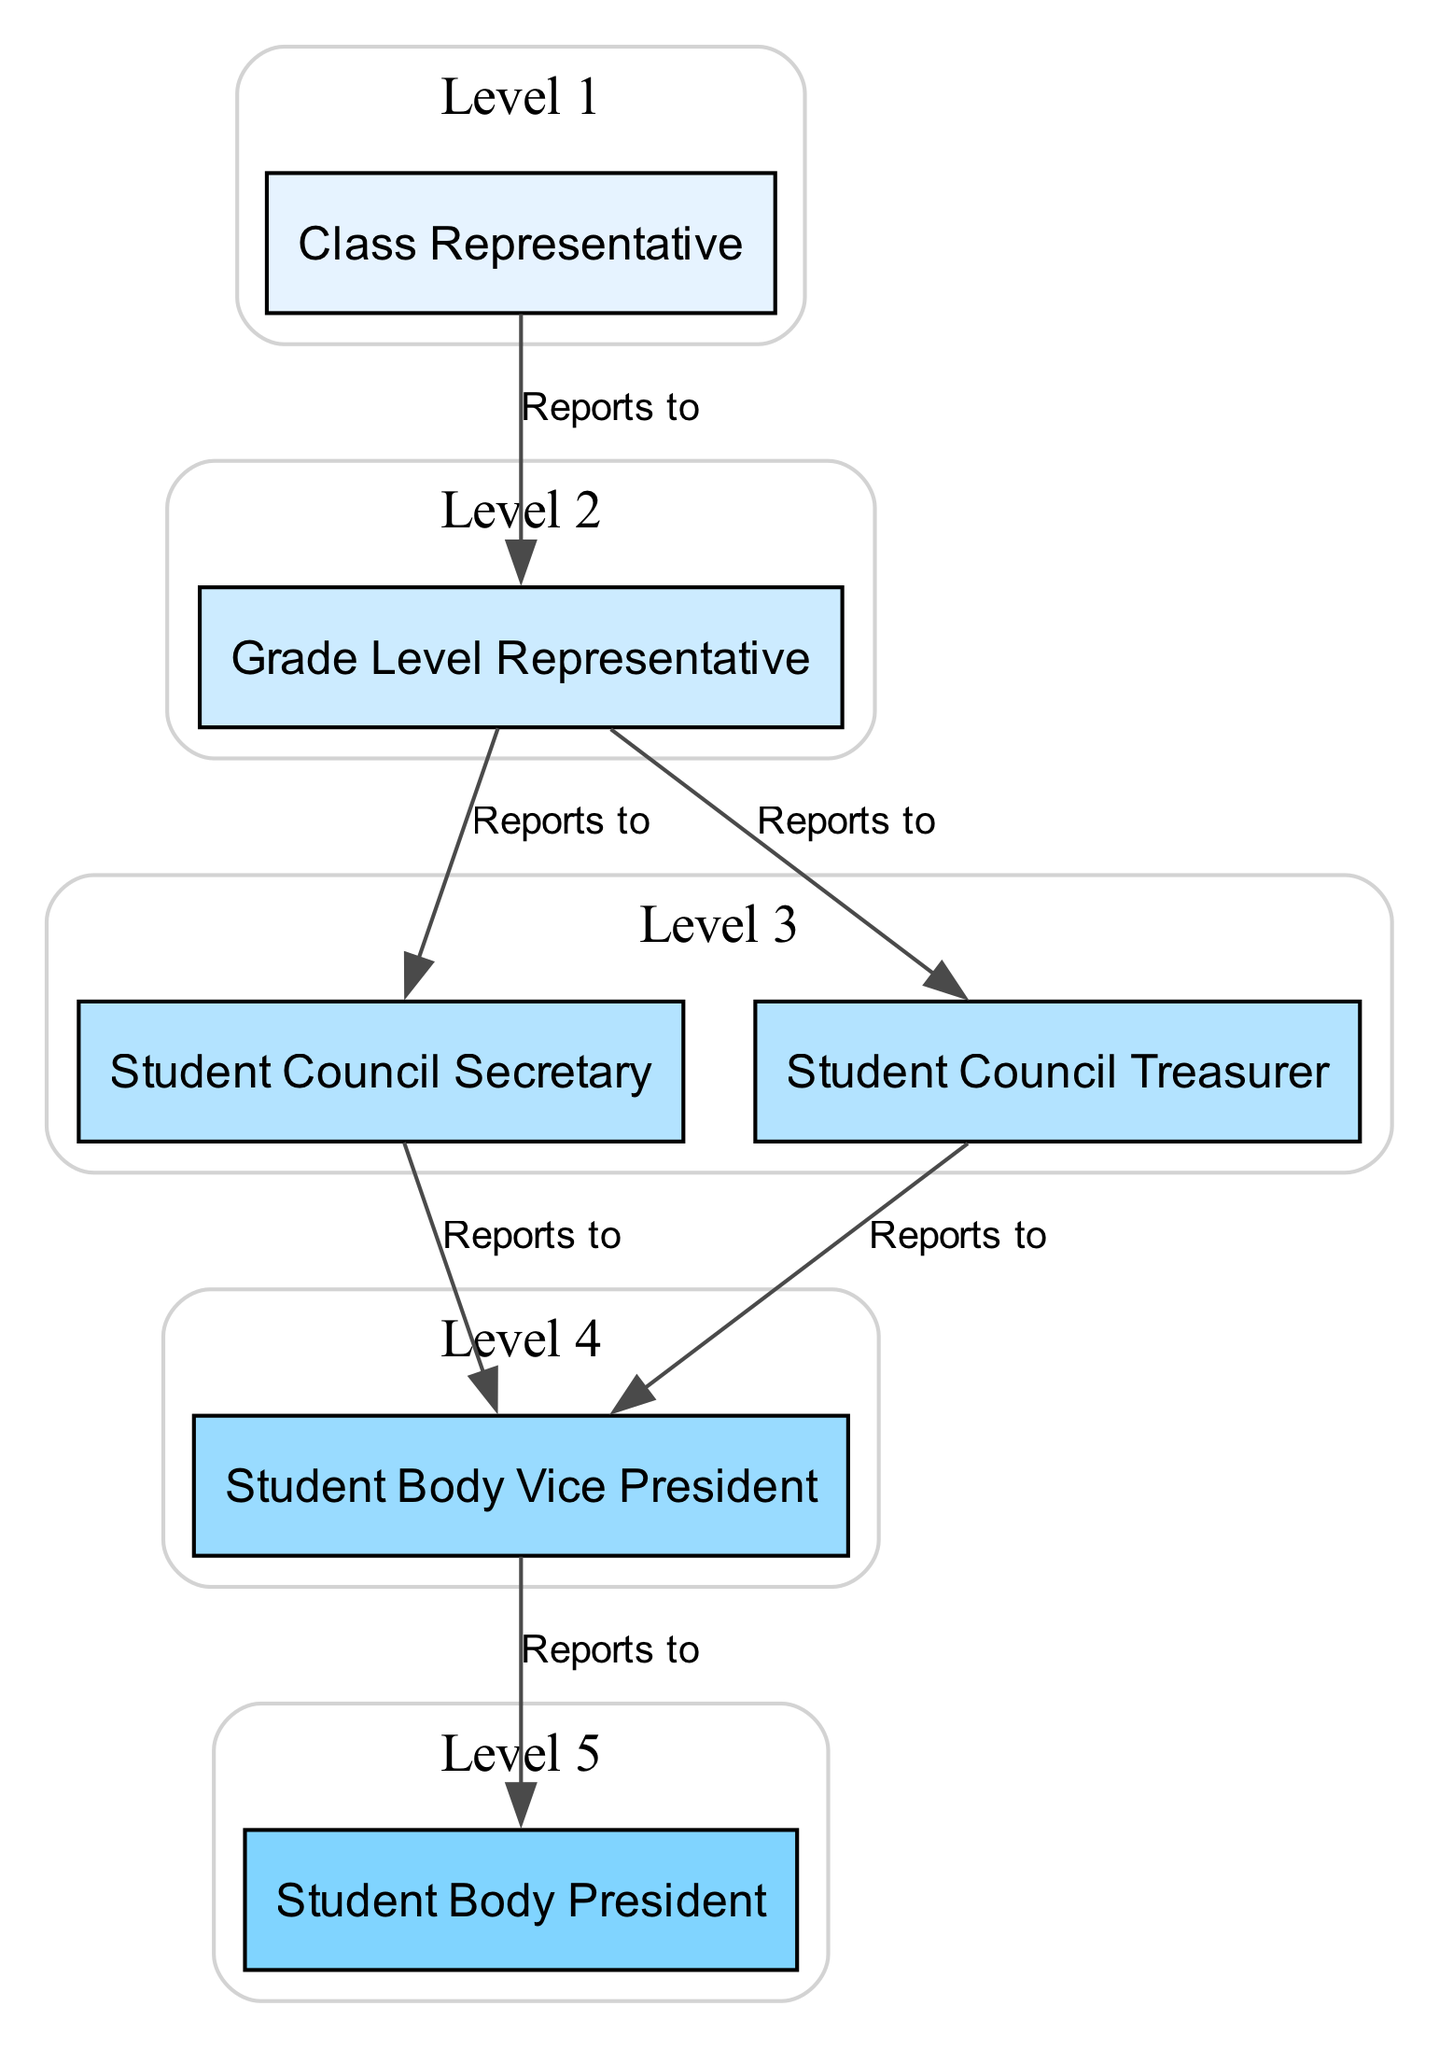What is the highest position in the student government hierarchy? The diagram shows a clear chain of command, with the highest position being the one that does not report to any other. This is the Student Body President.
Answer: Student Body President How many students report directly to the Vice President? To determine this, I look at the edges leading to the Vice President in the diagram. The edges show that both the Student Council Secretary and the Student Council Treasurer report directly to the Vice President. Therefore, the count is two.
Answer: 2 What position is directly below the Student Body President? The diagram indicates direct reporting lines. The Student Body Vice President reports directly to the Student Body President, as shown in the relationship arrow from the Vice President to the President.
Answer: Student Body Vice President Which level does the Class Representative belong to? The Class Representative is identified in the diagram with a specific label. The level of a node is indicated as 'level 1', which places it at the first tier in the hierarchy of the student government organization.
Answer: Level 1 What is the total number of roles depicted in the diagram? By counting the distinct elements listed in the diagram data, I see there are six roles: Class Representative, Grade Level Representative, Student Council Secretary, Student Council Treasurer, Student Body Vice President, and Student Body President. Thus, the total equals six.
Answer: 6 Which two positions share the same level in the hierarchy? The diagram indicates that the Student Council Secretary and Student Council Treasurer both fall under level three. By referencing the levels in the data, I can confirm these roles are equivalent in the hierarchy.
Answer: Student Council Secretary and Student Council Treasurer Who does the Grade Level Representative report to? The Grade Level Representative has arrows leading to both the Student Council Secretary and the Student Council Treasurer in the diagram, indicating it reports to both roles.
Answer: Student Council Secretary and Student Council Treasurer What is the relationship between the Class Representative and the Grade Level Representative? The diagram shows a directional relationship where the Class Representative reports to the Grade Level Representative, visualized with an arrow pointing from the Class Representative to the Grade Level Representative.
Answer: Reports to 